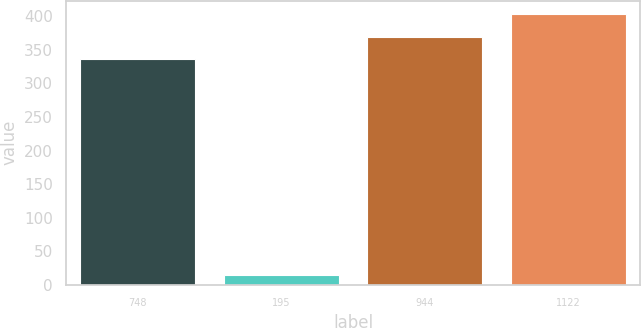Convert chart to OTSL. <chart><loc_0><loc_0><loc_500><loc_500><bar_chart><fcel>748<fcel>195<fcel>944<fcel>1122<nl><fcel>336<fcel>15<fcel>369.6<fcel>403.2<nl></chart> 